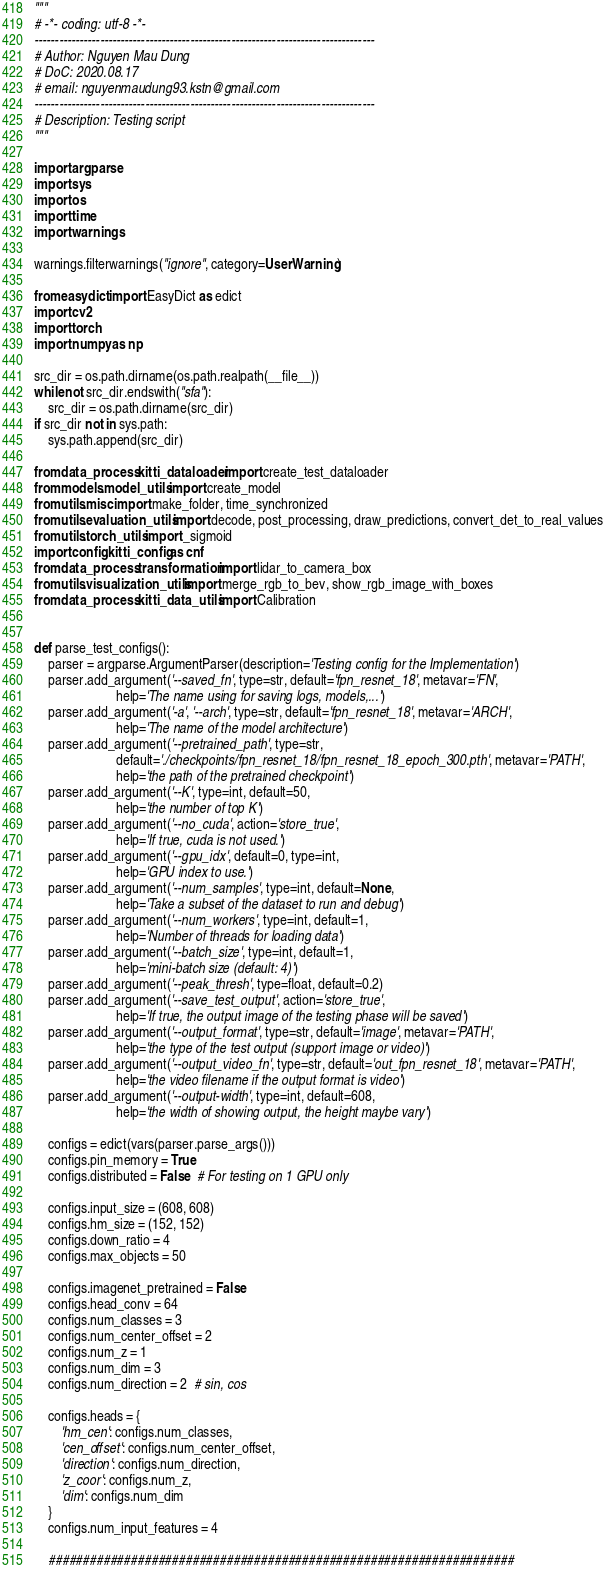<code> <loc_0><loc_0><loc_500><loc_500><_Python_>"""
# -*- coding: utf-8 -*-
-----------------------------------------------------------------------------------
# Author: Nguyen Mau Dung
# DoC: 2020.08.17
# email: nguyenmaudung93.kstn@gmail.com
-----------------------------------------------------------------------------------
# Description: Testing script
"""

import argparse
import sys
import os
import time
import warnings

warnings.filterwarnings("ignore", category=UserWarning)

from easydict import EasyDict as edict
import cv2
import torch
import numpy as np

src_dir = os.path.dirname(os.path.realpath(__file__))
while not src_dir.endswith("sfa"):
    src_dir = os.path.dirname(src_dir)
if src_dir not in sys.path:
    sys.path.append(src_dir)

from data_process.kitti_dataloader import create_test_dataloader
from models.model_utils import create_model
from utils.misc import make_folder, time_synchronized
from utils.evaluation_utils import decode, post_processing, draw_predictions, convert_det_to_real_values
from utils.torch_utils import _sigmoid
import config.kitti_config as cnf
from data_process.transformation import lidar_to_camera_box
from utils.visualization_utils import merge_rgb_to_bev, show_rgb_image_with_boxes
from data_process.kitti_data_utils import Calibration


def parse_test_configs():
    parser = argparse.ArgumentParser(description='Testing config for the Implementation')
    parser.add_argument('--saved_fn', type=str, default='fpn_resnet_18', metavar='FN',
                        help='The name using for saving logs, models,...')
    parser.add_argument('-a', '--arch', type=str, default='fpn_resnet_18', metavar='ARCH',
                        help='The name of the model architecture')
    parser.add_argument('--pretrained_path', type=str,
                        default='./checkpoints/fpn_resnet_18/fpn_resnet_18_epoch_300.pth', metavar='PATH',
                        help='the path of the pretrained checkpoint')
    parser.add_argument('--K', type=int, default=50,
                        help='the number of top K')
    parser.add_argument('--no_cuda', action='store_true',
                        help='If true, cuda is not used.')
    parser.add_argument('--gpu_idx', default=0, type=int,
                        help='GPU index to use.')
    parser.add_argument('--num_samples', type=int, default=None,
                        help='Take a subset of the dataset to run and debug')
    parser.add_argument('--num_workers', type=int, default=1,
                        help='Number of threads for loading data')
    parser.add_argument('--batch_size', type=int, default=1,
                        help='mini-batch size (default: 4)')
    parser.add_argument('--peak_thresh', type=float, default=0.2)
    parser.add_argument('--save_test_output', action='store_true',
                        help='If true, the output image of the testing phase will be saved')
    parser.add_argument('--output_format', type=str, default='image', metavar='PATH',
                        help='the type of the test output (support image or video)')
    parser.add_argument('--output_video_fn', type=str, default='out_fpn_resnet_18', metavar='PATH',
                        help='the video filename if the output format is video')
    parser.add_argument('--output-width', type=int, default=608,
                        help='the width of showing output, the height maybe vary')

    configs = edict(vars(parser.parse_args()))
    configs.pin_memory = True
    configs.distributed = False  # For testing on 1 GPU only

    configs.input_size = (608, 608)
    configs.hm_size = (152, 152)
    configs.down_ratio = 4
    configs.max_objects = 50

    configs.imagenet_pretrained = False
    configs.head_conv = 64
    configs.num_classes = 3
    configs.num_center_offset = 2
    configs.num_z = 1
    configs.num_dim = 3
    configs.num_direction = 2  # sin, cos

    configs.heads = {
        'hm_cen': configs.num_classes,
        'cen_offset': configs.num_center_offset,
        'direction': configs.num_direction,
        'z_coor': configs.num_z,
        'dim': configs.num_dim
    }
    configs.num_input_features = 4

    ####################################################################</code> 